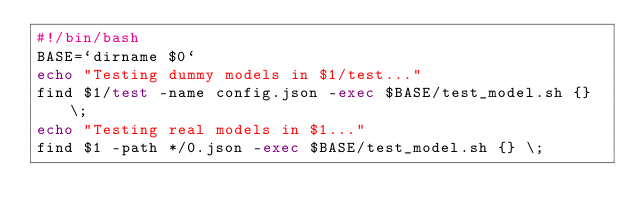Convert code to text. <code><loc_0><loc_0><loc_500><loc_500><_Bash_>#!/bin/bash
BASE=`dirname $0`
echo "Testing dummy models in $1/test..."
find $1/test -name config.json -exec $BASE/test_model.sh {} \;
echo "Testing real models in $1..."
find $1 -path */0.json -exec $BASE/test_model.sh {} \;
</code> 